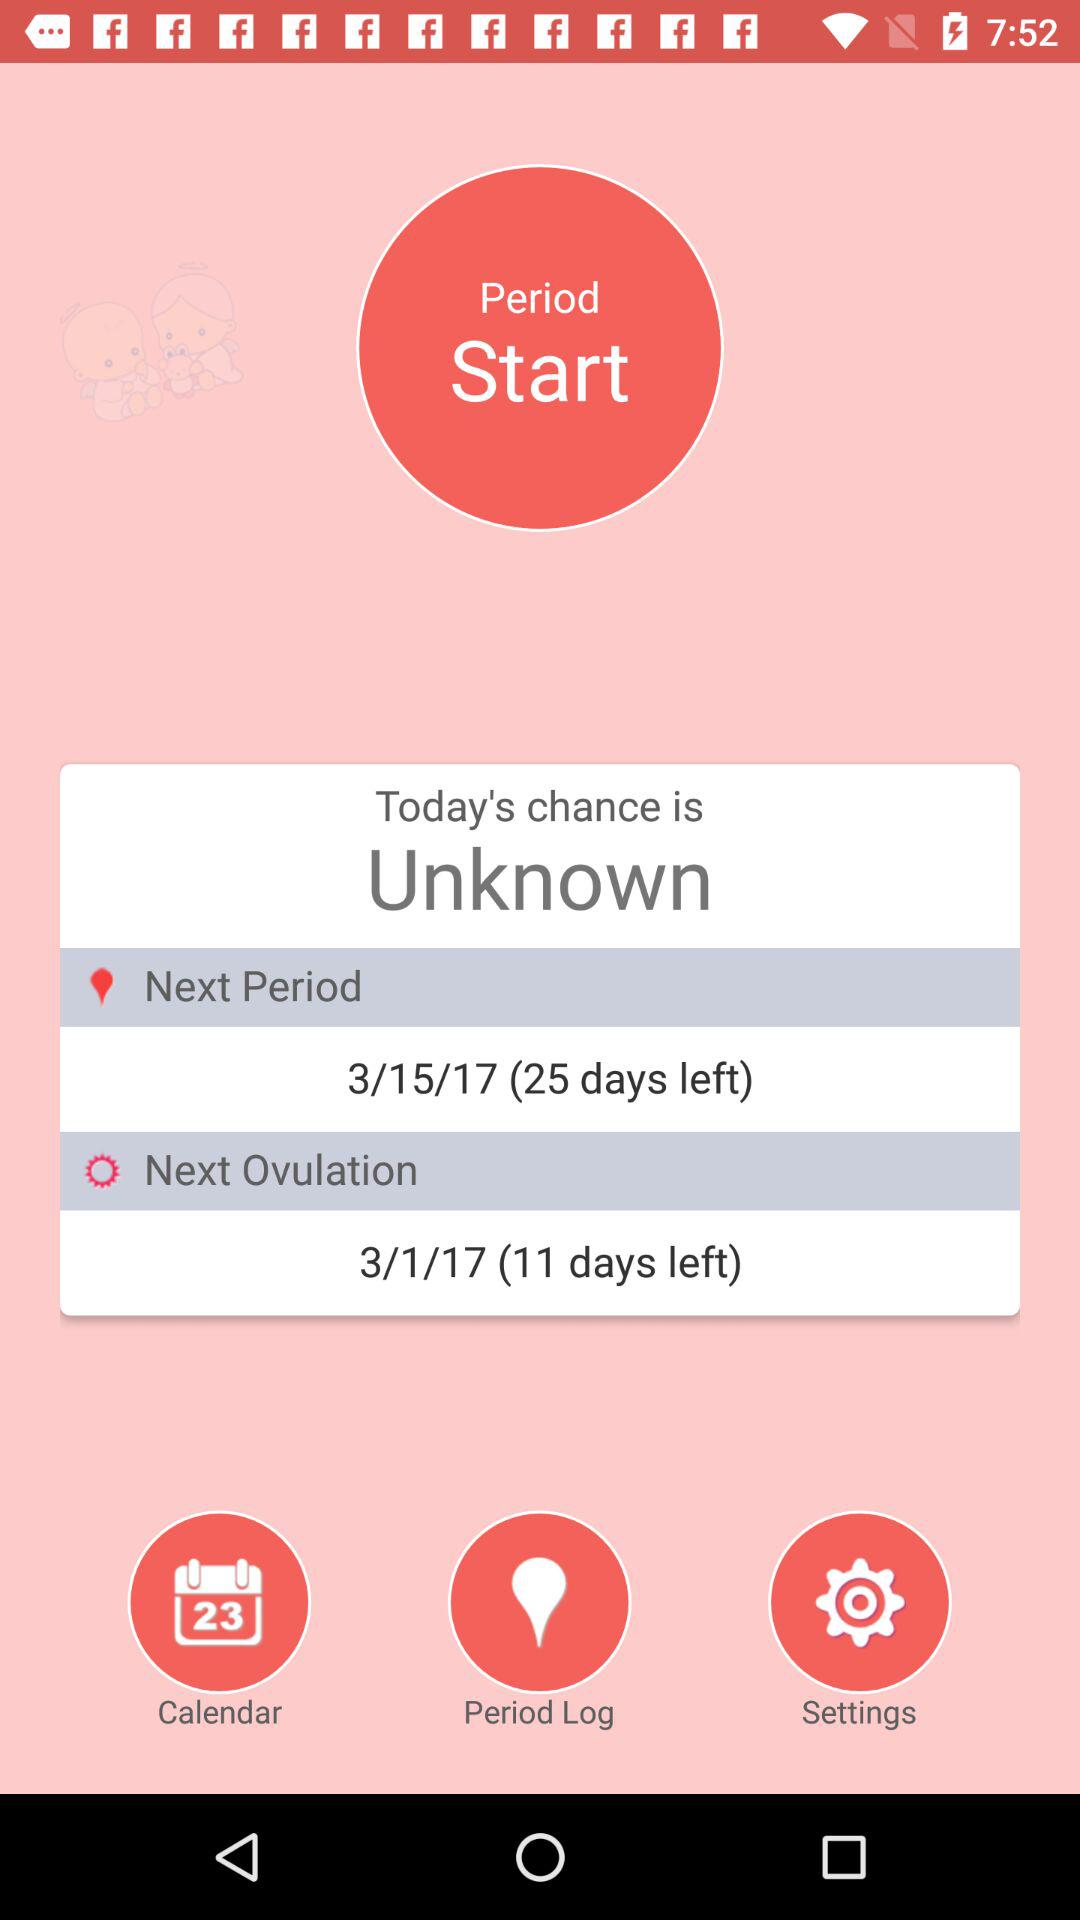What is the number of days left till the next period begins? The number of days left till the next period begins is 25. 